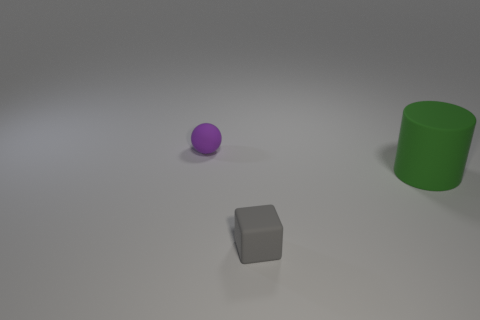Add 2 tiny brown metallic things. How many objects exist? 5 Subtract all cylinders. How many objects are left? 2 Subtract 0 brown cubes. How many objects are left? 3 Subtract all big green objects. Subtract all tiny purple rubber objects. How many objects are left? 1 Add 2 tiny purple objects. How many tiny purple objects are left? 3 Add 3 tiny rubber cubes. How many tiny rubber cubes exist? 4 